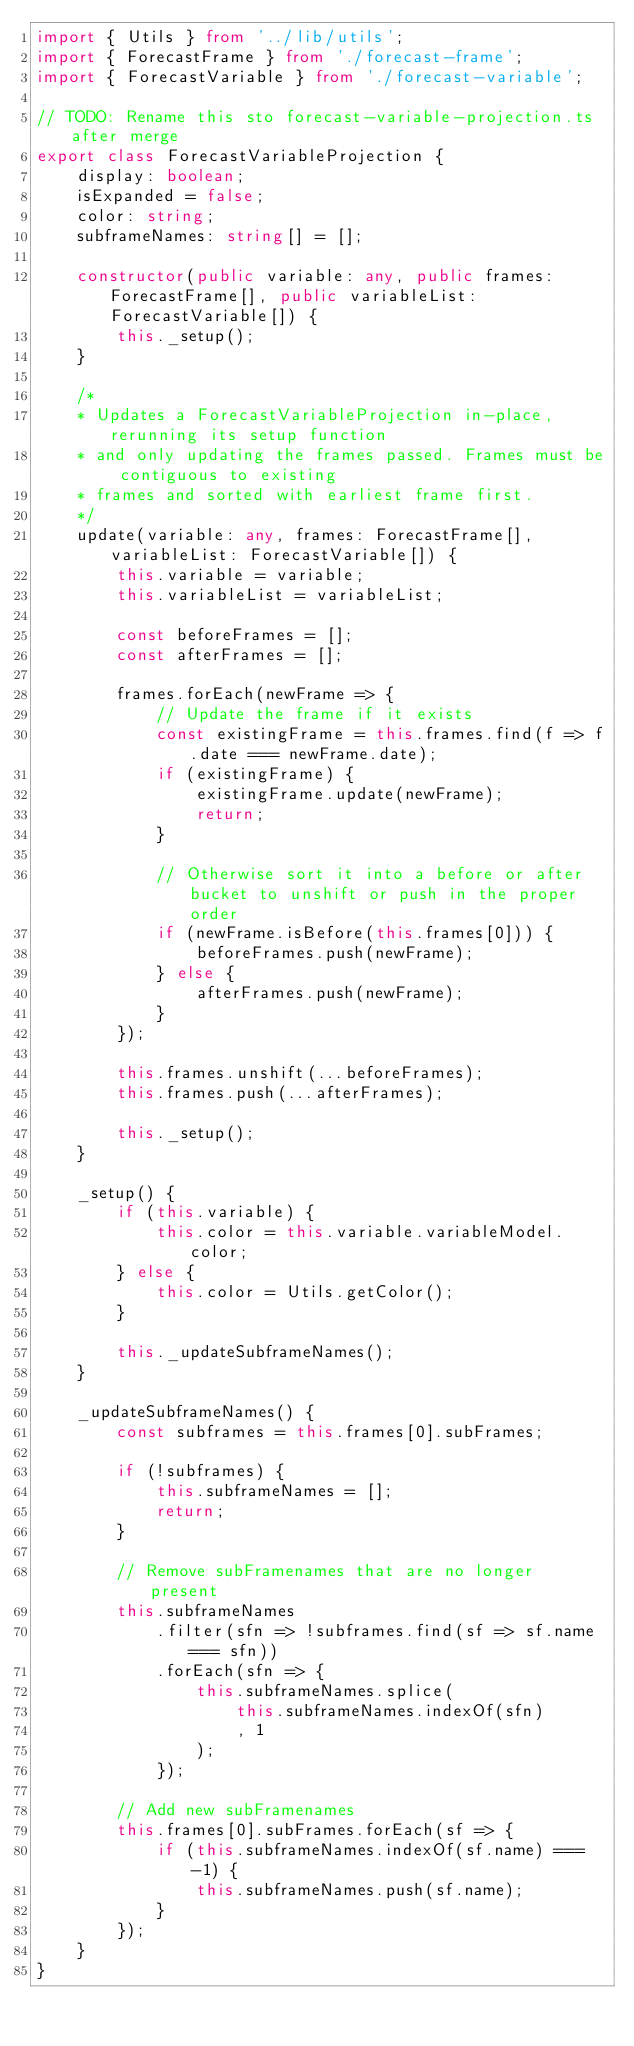<code> <loc_0><loc_0><loc_500><loc_500><_TypeScript_>import { Utils } from '../lib/utils';
import { ForecastFrame } from './forecast-frame';
import { ForecastVariable } from './forecast-variable';

// TODO: Rename this sto forecast-variable-projection.ts after merge
export class ForecastVariableProjection {
    display: boolean;
    isExpanded = false;
    color: string;
    subframeNames: string[] = [];

    constructor(public variable: any, public frames: ForecastFrame[], public variableList: ForecastVariable[]) {
        this._setup();
    }

    /*
    * Updates a ForecastVariableProjection in-place, rerunning its setup function
    * and only updating the frames passed. Frames must be contiguous to existing
    * frames and sorted with earliest frame first.
    */
    update(variable: any, frames: ForecastFrame[], variableList: ForecastVariable[]) {
        this.variable = variable;
        this.variableList = variableList;

        const beforeFrames = [];
        const afterFrames = [];

        frames.forEach(newFrame => {
            // Update the frame if it exists
            const existingFrame = this.frames.find(f => f.date === newFrame.date);
            if (existingFrame) {
                existingFrame.update(newFrame);
                return;
            }

            // Otherwise sort it into a before or after bucket to unshift or push in the proper order
            if (newFrame.isBefore(this.frames[0])) {
                beforeFrames.push(newFrame);
            } else {
                afterFrames.push(newFrame);
            }
        });

        this.frames.unshift(...beforeFrames);
        this.frames.push(...afterFrames);

        this._setup();
    }

    _setup() {
        if (this.variable) {
            this.color = this.variable.variableModel.color;
        } else {
            this.color = Utils.getColor();
        }

        this._updateSubframeNames();
    }

    _updateSubframeNames() {
        const subframes = this.frames[0].subFrames;

        if (!subframes) {
            this.subframeNames = [];
            return;
        }

        // Remove subFramenames that are no longer present
        this.subframeNames
            .filter(sfn => !subframes.find(sf => sf.name === sfn))
            .forEach(sfn => {
                this.subframeNames.splice(
                    this.subframeNames.indexOf(sfn)
                    , 1
                );
            });

        // Add new subFramenames
        this.frames[0].subFrames.forEach(sf => {
            if (this.subframeNames.indexOf(sf.name) === -1) {
                this.subframeNames.push(sf.name);
            }
        });
    }
}
</code> 